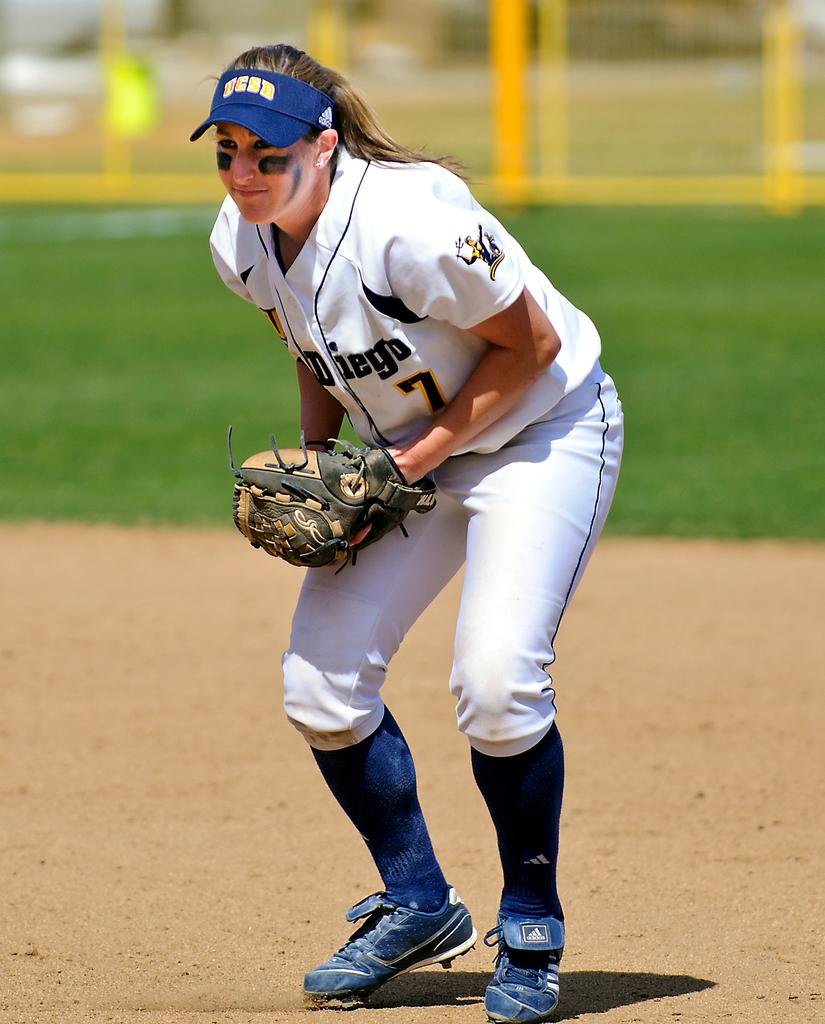What number does the player wear?
Your answer should be compact. 7. 